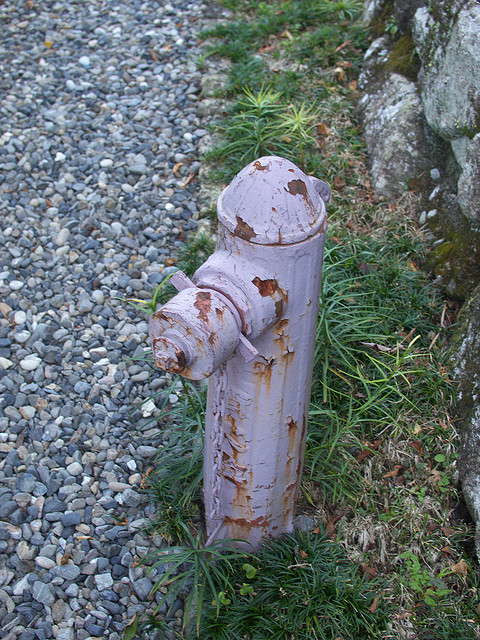Based on the visible elements around the fireplug, construct a realistic scenario where it might be used. In a realistic scenario, the fireplug might be called into action during a nearby small brushfire. The area, though not heavily trafficked, could have dry patches of grass and weeds that might catch fire during a particularly hot and dry season. A passerby notices smoke and calls the local fire department. Firefighters arrive promptly and connect their hoses to the fireplug, drawing water to quickly extinguish the flames before they can spread to any nearby structures. The fireplug, despite its weather-worn appearance, fulfills its purpose effectively, protecting the area and preventing further damage. 